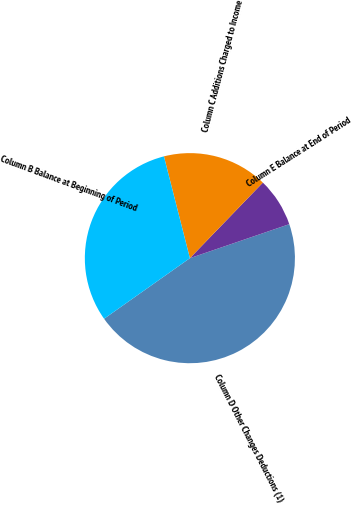Convert chart. <chart><loc_0><loc_0><loc_500><loc_500><pie_chart><fcel>Column D Other Changes Deductions (1)<fcel>Column E Balance at End of Period<fcel>Column C Additions Charged to Income<fcel>Column B Balance at Beginning of Period<nl><fcel>45.46%<fcel>7.53%<fcel>16.2%<fcel>30.81%<nl></chart> 